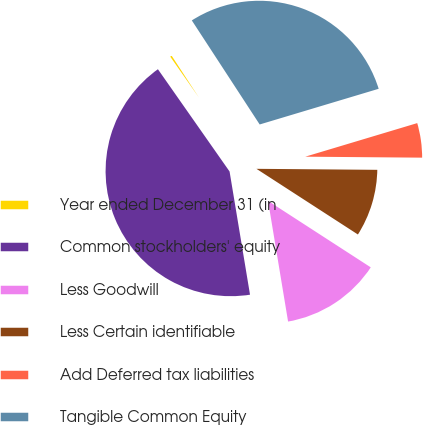<chart> <loc_0><loc_0><loc_500><loc_500><pie_chart><fcel>Year ended December 31 (in<fcel>Common stockholders' equity<fcel>Less Goodwill<fcel>Less Certain identifiable<fcel>Add Deferred tax liabilities<fcel>Tangible Common Equity<nl><fcel>0.53%<fcel>42.89%<fcel>13.24%<fcel>9.01%<fcel>4.77%<fcel>29.56%<nl></chart> 